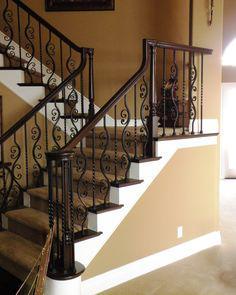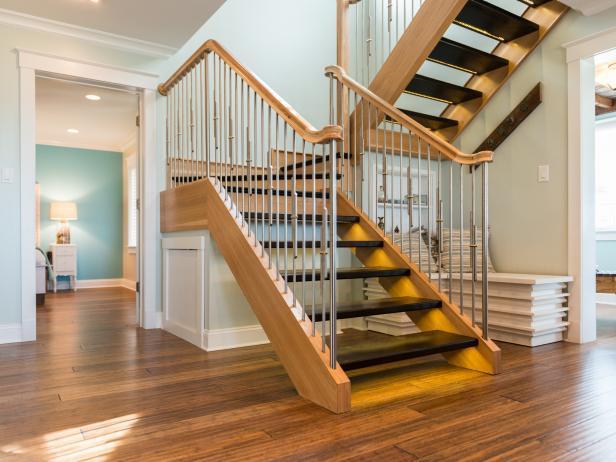The first image is the image on the left, the second image is the image on the right. Given the left and right images, does the statement "The left image shows a staircase that ascends rightward before turning and has black wrought iron rails with scroll shapes." hold true? Answer yes or no. Yes. The first image is the image on the left, the second image is the image on the right. Evaluate the accuracy of this statement regarding the images: "At least one stairway has white side railings.". Is it true? Answer yes or no. No. 